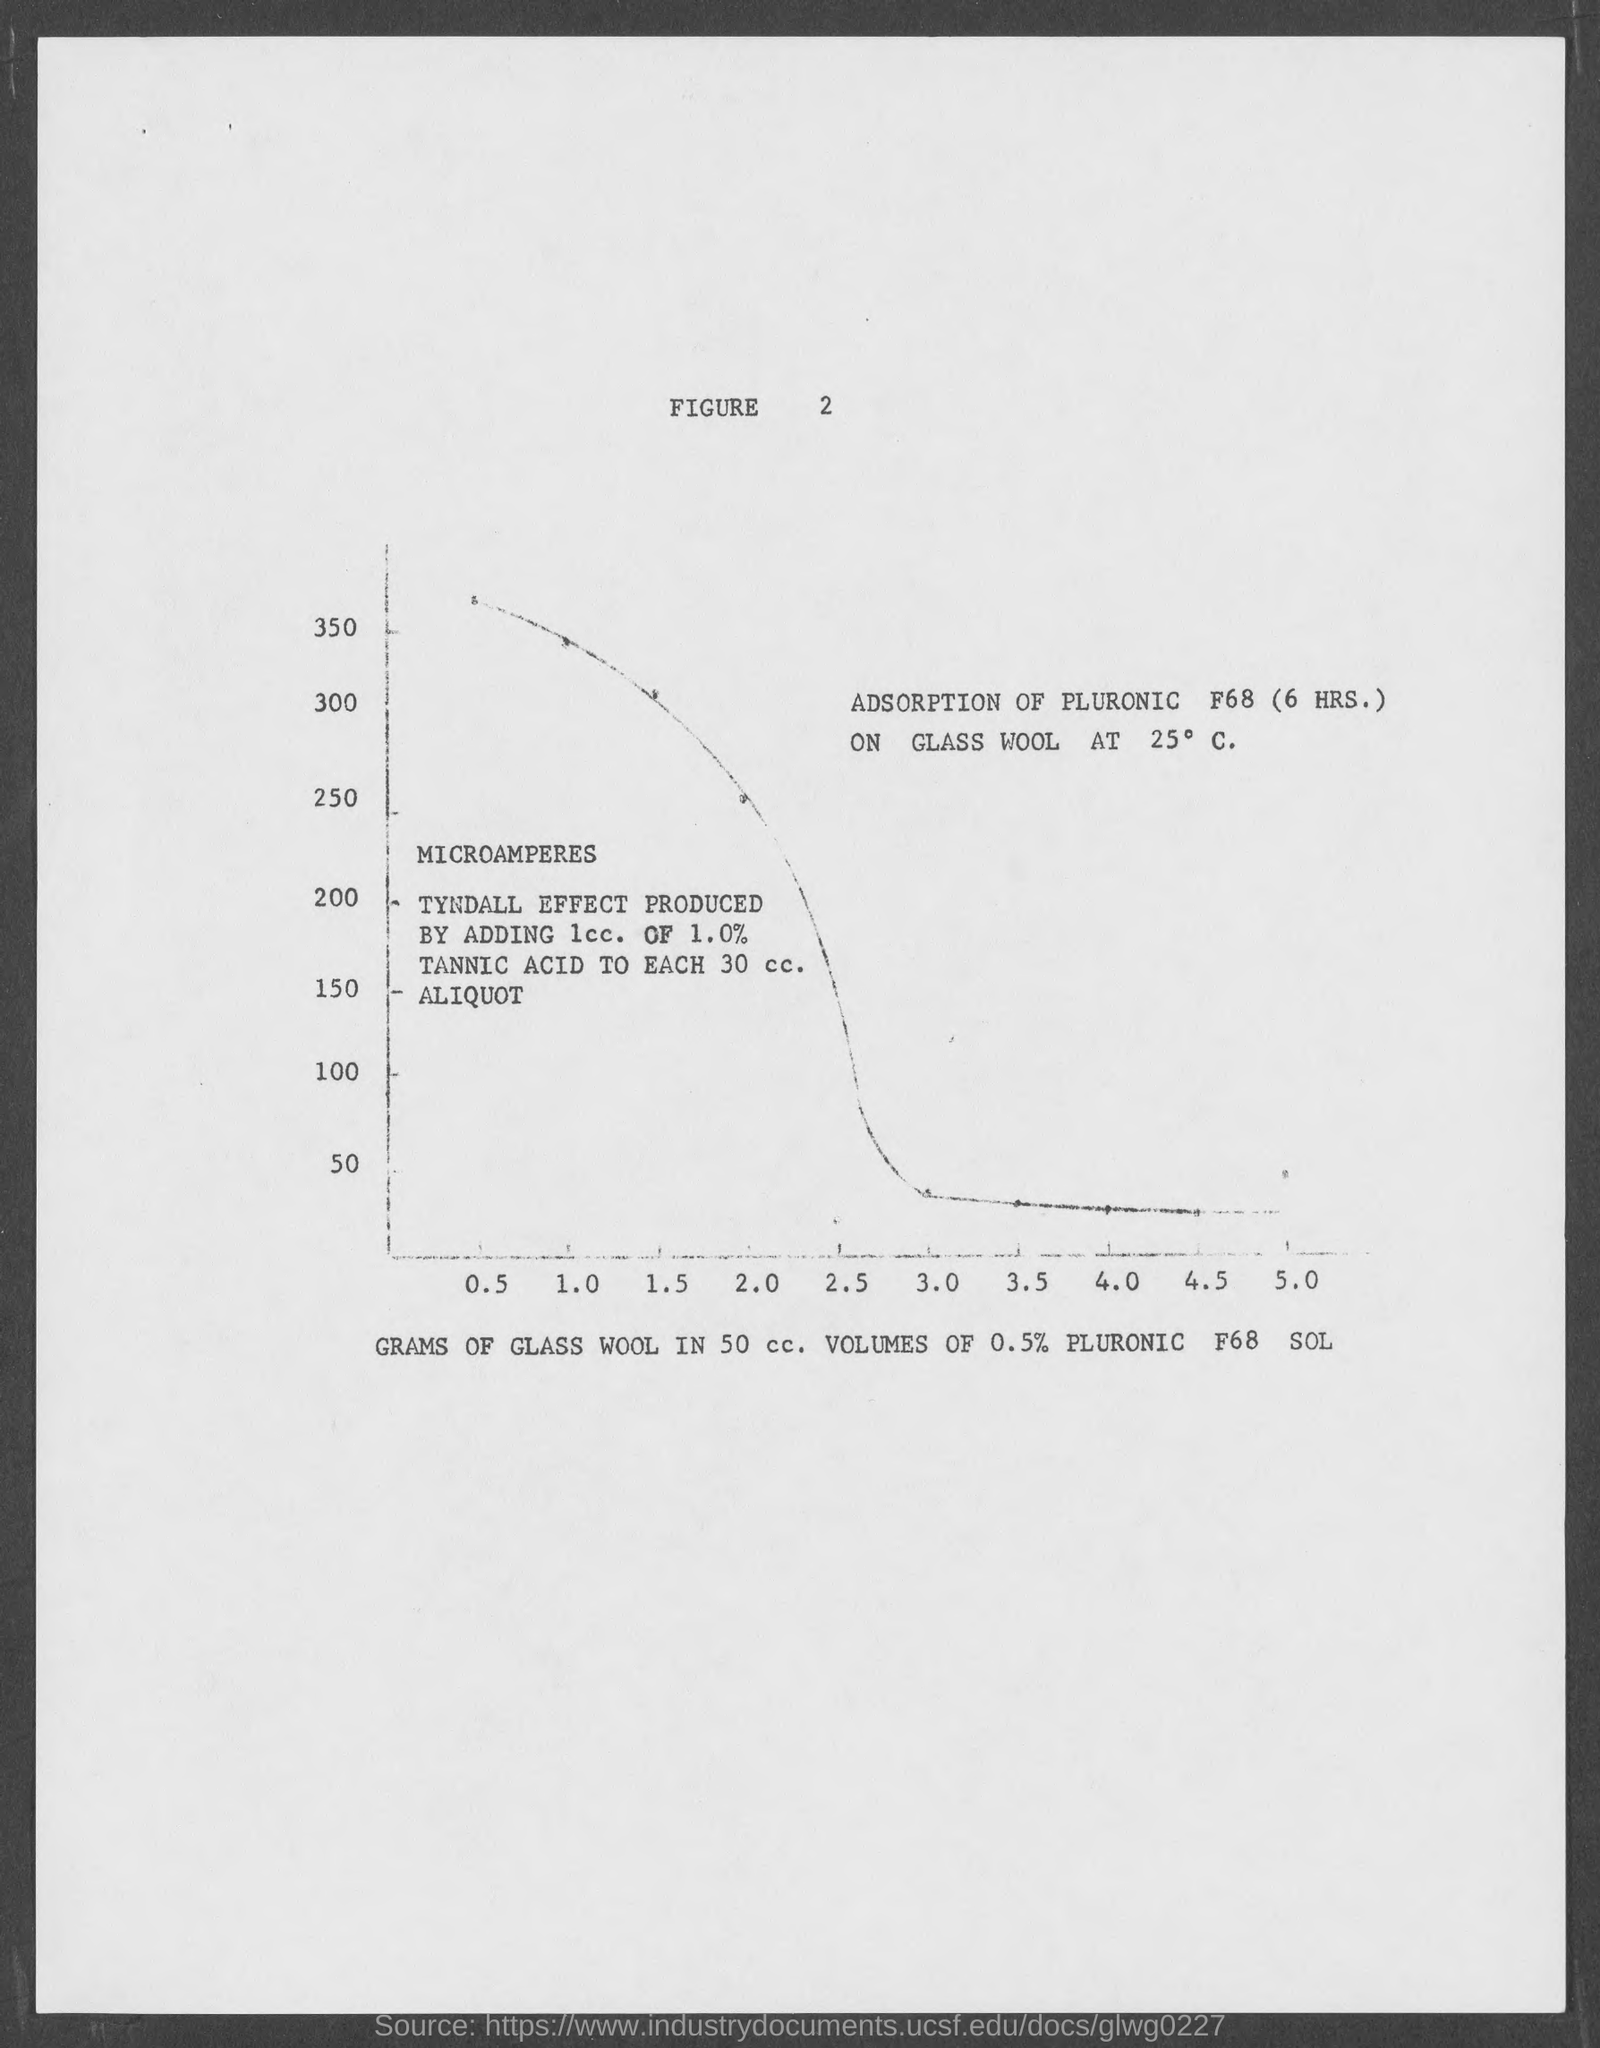What is the figure number?
Offer a very short reply. 2. 